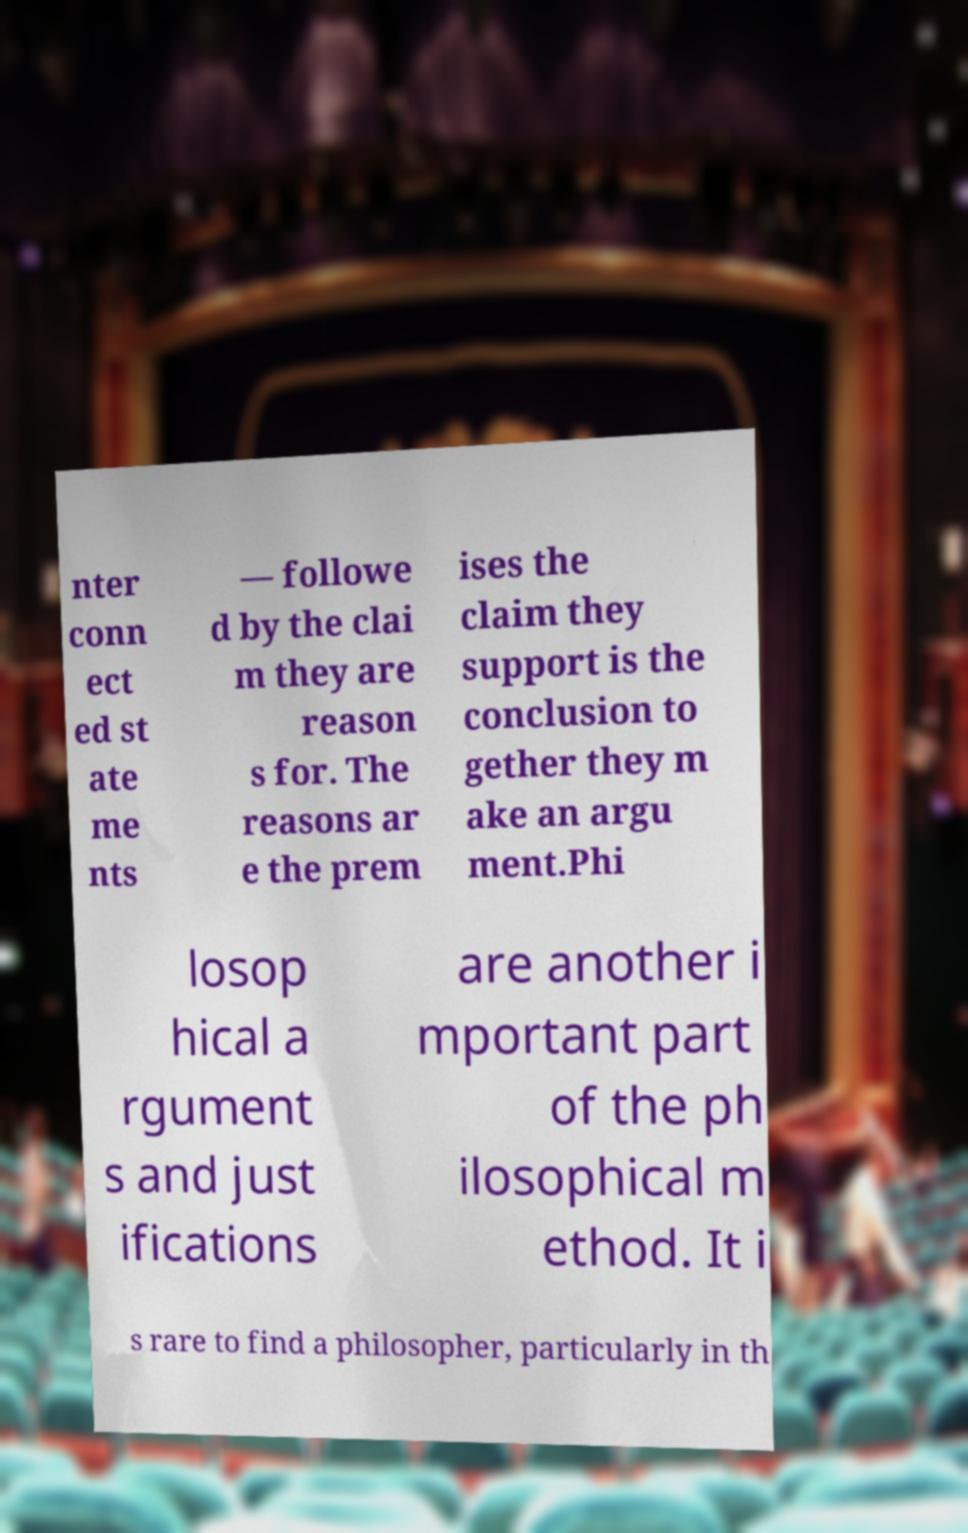Can you accurately transcribe the text from the provided image for me? nter conn ect ed st ate me nts — followe d by the clai m they are reason s for. The reasons ar e the prem ises the claim they support is the conclusion to gether they m ake an argu ment.Phi losop hical a rgument s and just ifications are another i mportant part of the ph ilosophical m ethod. It i s rare to find a philosopher, particularly in th 